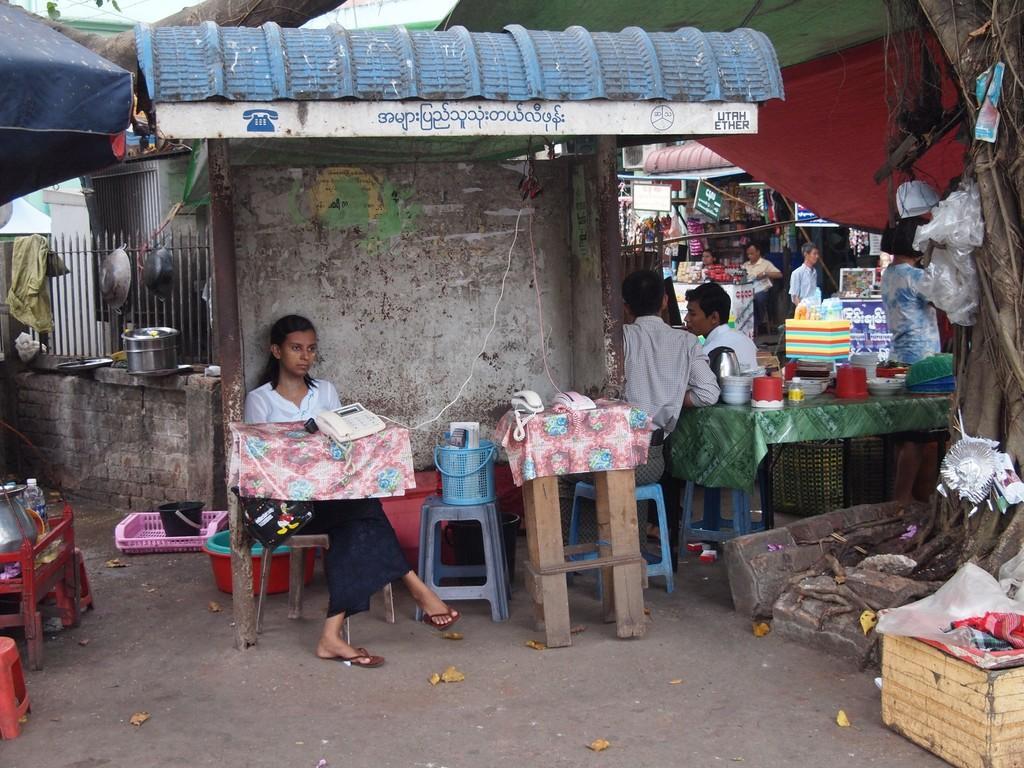Could you give a brief overview of what you see in this image? In this image we can see a girl sitting on the chair which is on the surface under the tent for shelter. We can also see the tables with the phones. Image also consists of stools, tubs, tray with a black color bucket, some vessels and also the persons sitting on the stools. We can also see the table with bowls, bottle and some other objects. On the right we can see the tree with the covers. We can also see the wooden box, dried leaves, wall with the fence, stall with the persons and also the tents for shelter. 